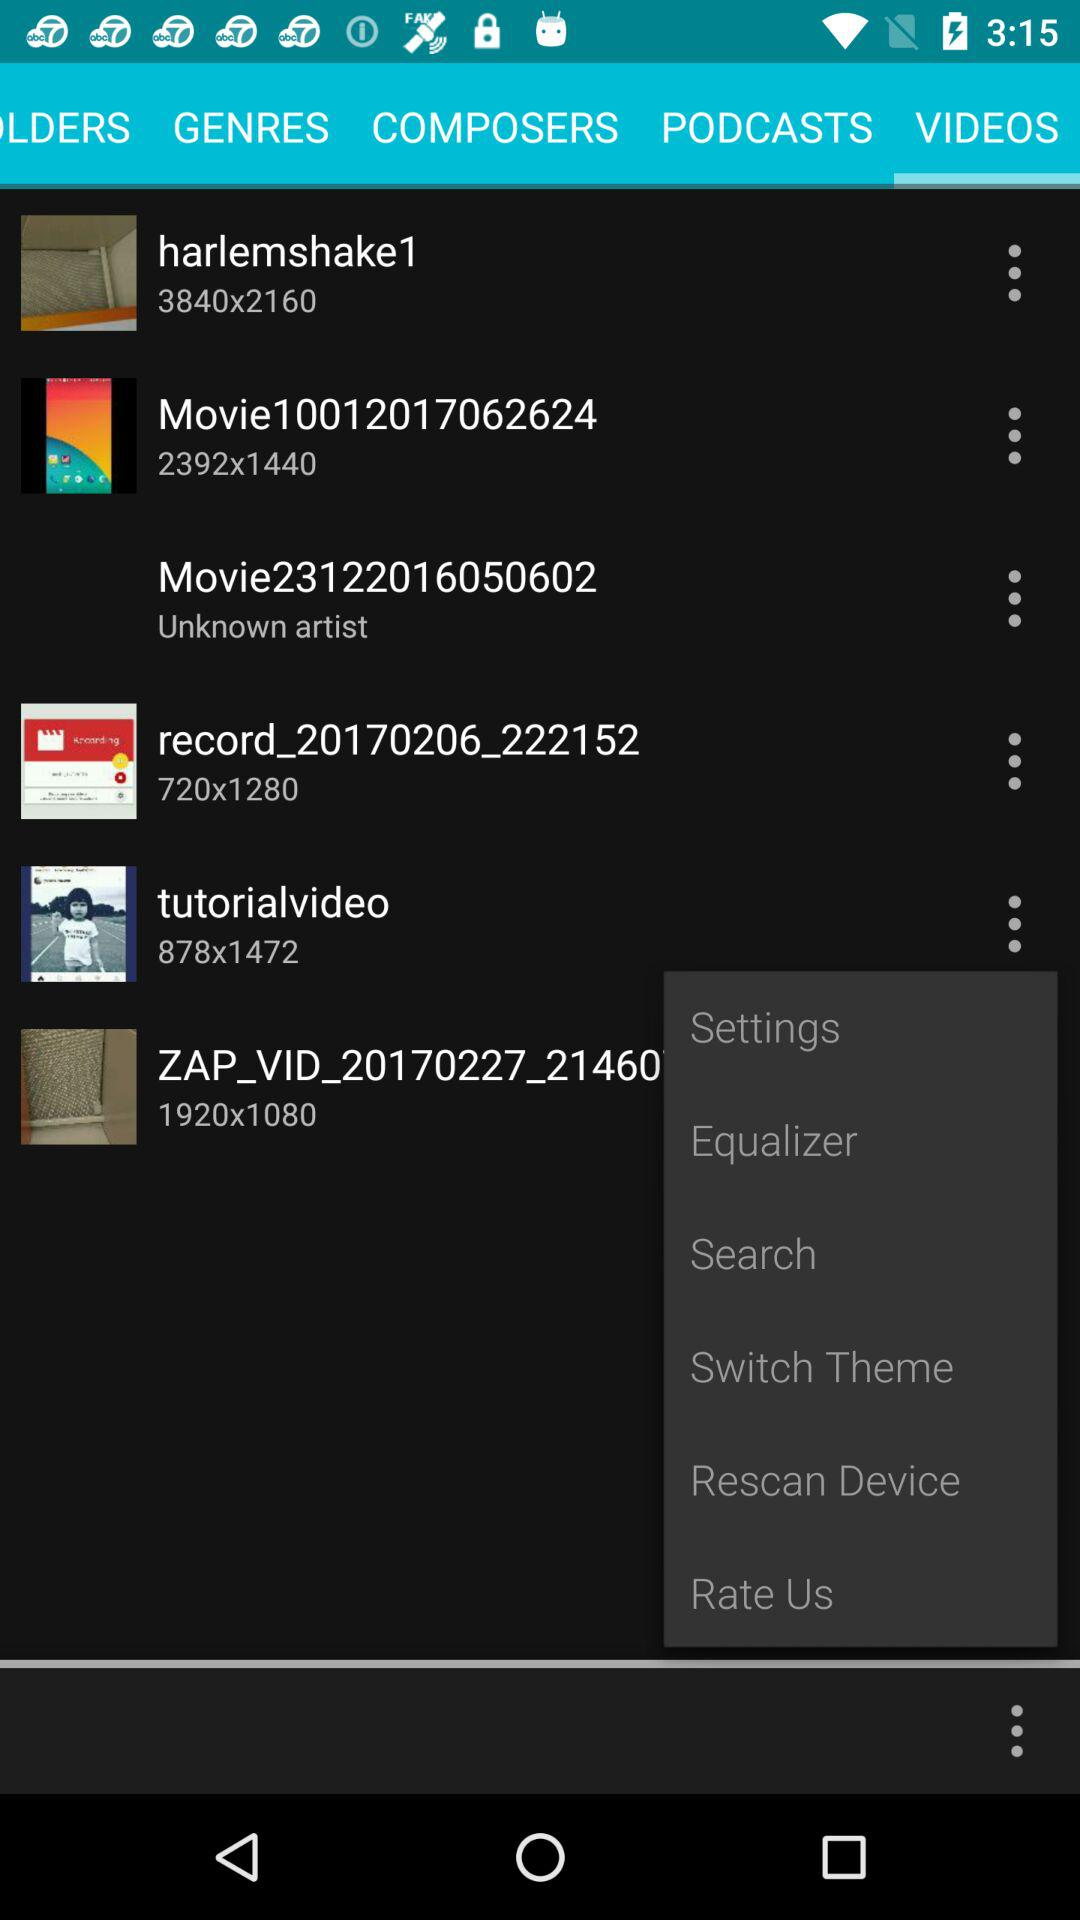How many items have a text label of 'Movie'?
Answer the question using a single word or phrase. 2 